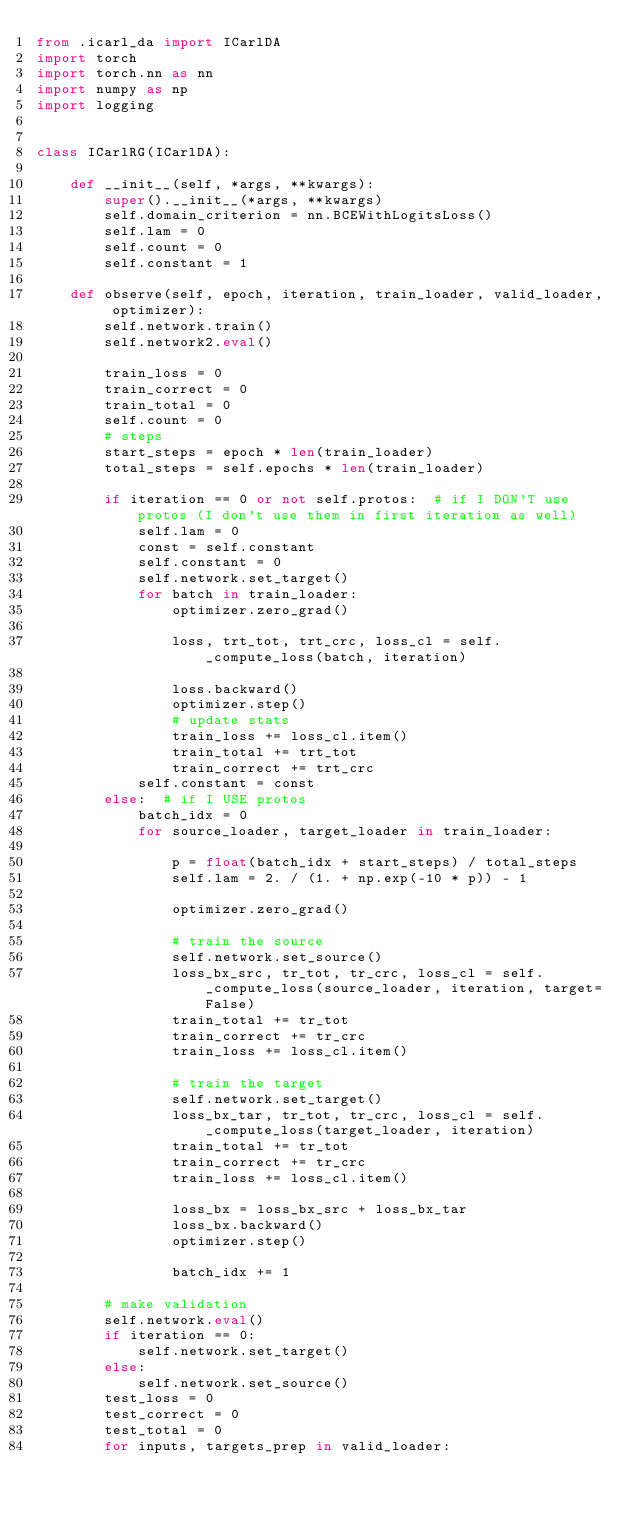<code> <loc_0><loc_0><loc_500><loc_500><_Python_>from .icarl_da import ICarlDA
import torch
import torch.nn as nn
import numpy as np
import logging


class ICarlRG(ICarlDA):

    def __init__(self, *args, **kwargs):
        super().__init__(*args, **kwargs)
        self.domain_criterion = nn.BCEWithLogitsLoss()
        self.lam = 0
        self.count = 0
        self.constant = 1

    def observe(self, epoch, iteration, train_loader, valid_loader, optimizer):
        self.network.train()
        self.network2.eval()

        train_loss = 0
        train_correct = 0
        train_total = 0
        self.count = 0
        # steps
        start_steps = epoch * len(train_loader)
        total_steps = self.epochs * len(train_loader)

        if iteration == 0 or not self.protos:  # if I DON'T use protos (I don't use them in first iteration as well)
            self.lam = 0
            const = self.constant
            self.constant = 0
            self.network.set_target()
            for batch in train_loader:
                optimizer.zero_grad()

                loss, trt_tot, trt_crc, loss_cl = self._compute_loss(batch, iteration)

                loss.backward()
                optimizer.step()
                # update stats
                train_loss += loss_cl.item()
                train_total += trt_tot
                train_correct += trt_crc
            self.constant = const
        else:  # if I USE protos
            batch_idx = 0
            for source_loader, target_loader in train_loader:

                p = float(batch_idx + start_steps) / total_steps
                self.lam = 2. / (1. + np.exp(-10 * p)) - 1

                optimizer.zero_grad()

                # train the source
                self.network.set_source()
                loss_bx_src, tr_tot, tr_crc, loss_cl = self._compute_loss(source_loader, iteration, target=False)
                train_total += tr_tot
                train_correct += tr_crc
                train_loss += loss_cl.item()

                # train the target
                self.network.set_target()
                loss_bx_tar, tr_tot, tr_crc, loss_cl = self._compute_loss(target_loader, iteration)
                train_total += tr_tot
                train_correct += tr_crc
                train_loss += loss_cl.item()

                loss_bx = loss_bx_src + loss_bx_tar
                loss_bx.backward()
                optimizer.step()

                batch_idx += 1

        # make validation
        self.network.eval()
        if iteration == 0:
            self.network.set_target()
        else:
            self.network.set_source()
        test_loss = 0
        test_correct = 0
        test_total = 0
        for inputs, targets_prep in valid_loader:</code> 